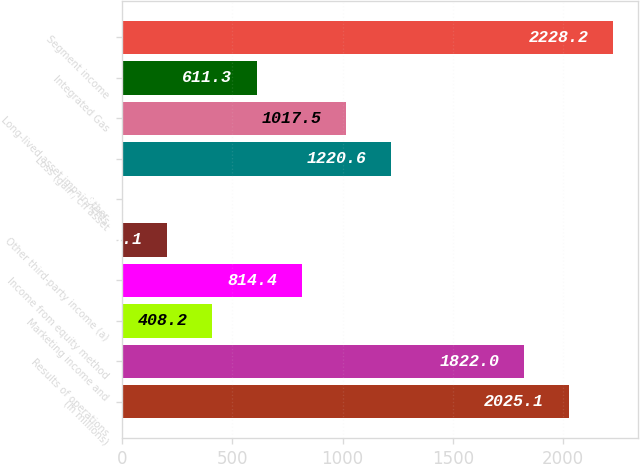<chart> <loc_0><loc_0><loc_500><loc_500><bar_chart><fcel>(In millions)<fcel>Results of operations<fcel>Marketing income and<fcel>Income from equity method<fcel>Other third-party income (a)<fcel>Other<fcel>Loss (gain) on asset<fcel>Long-lived asset impairments<fcel>Integrated Gas<fcel>Segment income<nl><fcel>2025.1<fcel>1822<fcel>408.2<fcel>814.4<fcel>205.1<fcel>2<fcel>1220.6<fcel>1017.5<fcel>611.3<fcel>2228.2<nl></chart> 